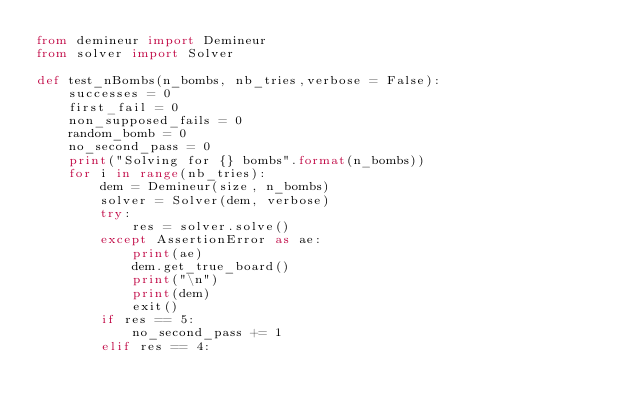<code> <loc_0><loc_0><loc_500><loc_500><_Python_>from demineur import Demineur
from solver import Solver

def test_nBombs(n_bombs, nb_tries,verbose = False):
    successes = 0
    first_fail = 0
    non_supposed_fails = 0
    random_bomb = 0
    no_second_pass = 0
    print("Solving for {} bombs".format(n_bombs))
    for i in range(nb_tries):
        dem = Demineur(size, n_bombs)
        solver = Solver(dem, verbose)
        try:
            res = solver.solve()
        except AssertionError as ae:
            print(ae)
            dem.get_true_board()
            print("\n")
            print(dem)
            exit()
        if res == 5:
            no_second_pass += 1
        elif res == 4:</code> 